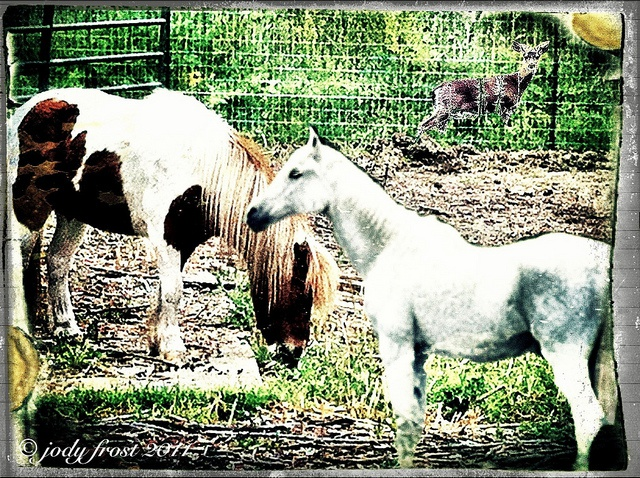Describe the objects in this image and their specific colors. I can see horse in black, ivory, tan, and maroon tones and horse in black, ivory, darkgray, and teal tones in this image. 